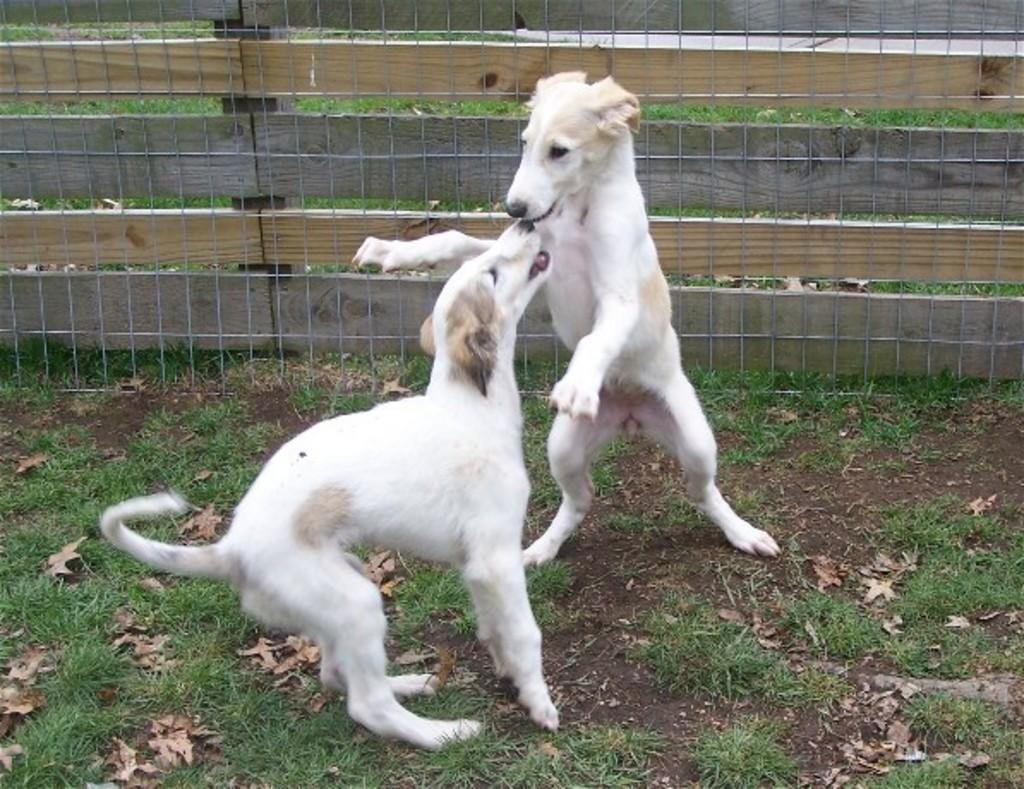How many dogs are in the image? There are two dogs in the image. What are the dogs doing in the image? The dogs are playing on the ground. What can be seen behind the dogs in the image? There is a wooden fence with a net in the image. What type of surface is the dogs playing on? There is grass on the ground, and dried leaves are also present. What type of skate is the dog using to play with the other dog in the image? There is no skate present in the image; the dogs are playing on the ground without any additional equipment. 